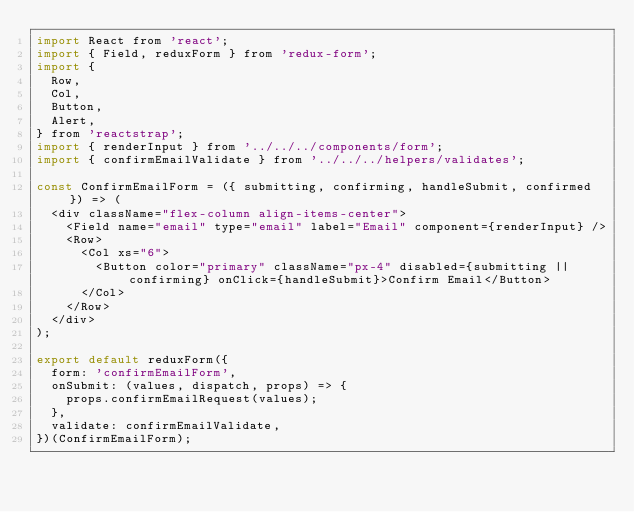Convert code to text. <code><loc_0><loc_0><loc_500><loc_500><_JavaScript_>import React from 'react';
import { Field, reduxForm } from 'redux-form';
import {
  Row,
  Col,
  Button,
  Alert,
} from 'reactstrap';
import { renderInput } from '../../../components/form';
import { confirmEmailValidate } from '../../../helpers/validates';

const ConfirmEmailForm = ({ submitting, confirming, handleSubmit, confirmed }) => (
  <div className="flex-column align-items-center">
    <Field name="email" type="email" label="Email" component={renderInput} />
    <Row>
      <Col xs="6">
        <Button color="primary" className="px-4" disabled={submitting || confirming} onClick={handleSubmit}>Confirm Email</Button>
      </Col>
    </Row>
  </div>
);

export default reduxForm({
  form: 'confirmEmailForm',
  onSubmit: (values, dispatch, props) => {
    props.confirmEmailRequest(values);
  },
  validate: confirmEmailValidate,
})(ConfirmEmailForm);
</code> 